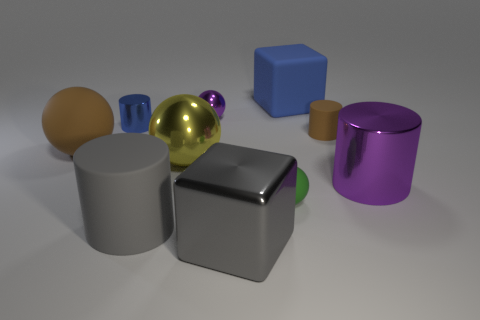Is the number of big yellow balls greater than the number of rubber things?
Make the answer very short. No. Does the small matte object that is in front of the tiny brown cylinder have the same shape as the yellow thing?
Your response must be concise. Yes. How many big objects are to the right of the big blue matte block and left of the big purple thing?
Provide a succinct answer. 0. What number of brown matte things have the same shape as the green matte object?
Your answer should be very brief. 1. What color is the large matte sphere that is on the left side of the purple metallic thing in front of the yellow sphere?
Your answer should be very brief. Brown. Is the shape of the big gray rubber object the same as the tiny matte object that is behind the large purple object?
Provide a short and direct response. Yes. There is a large gray thing on the left side of the small thing behind the blue object that is in front of the big blue thing; what is its material?
Ensure brevity in your answer.  Rubber. Is there a yellow metallic block that has the same size as the yellow ball?
Keep it short and to the point. No. There is a purple ball that is made of the same material as the blue cylinder; what size is it?
Provide a short and direct response. Small. What shape is the blue matte thing?
Provide a short and direct response. Cube. 